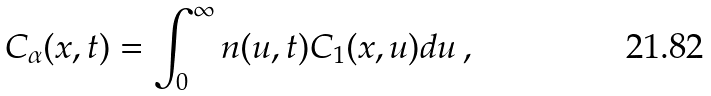<formula> <loc_0><loc_0><loc_500><loc_500>C _ { \alpha } ( x , t ) = \int _ { 0 } ^ { \infty } n ( u , t ) C _ { 1 } ( x , u ) d u \, ,</formula> 